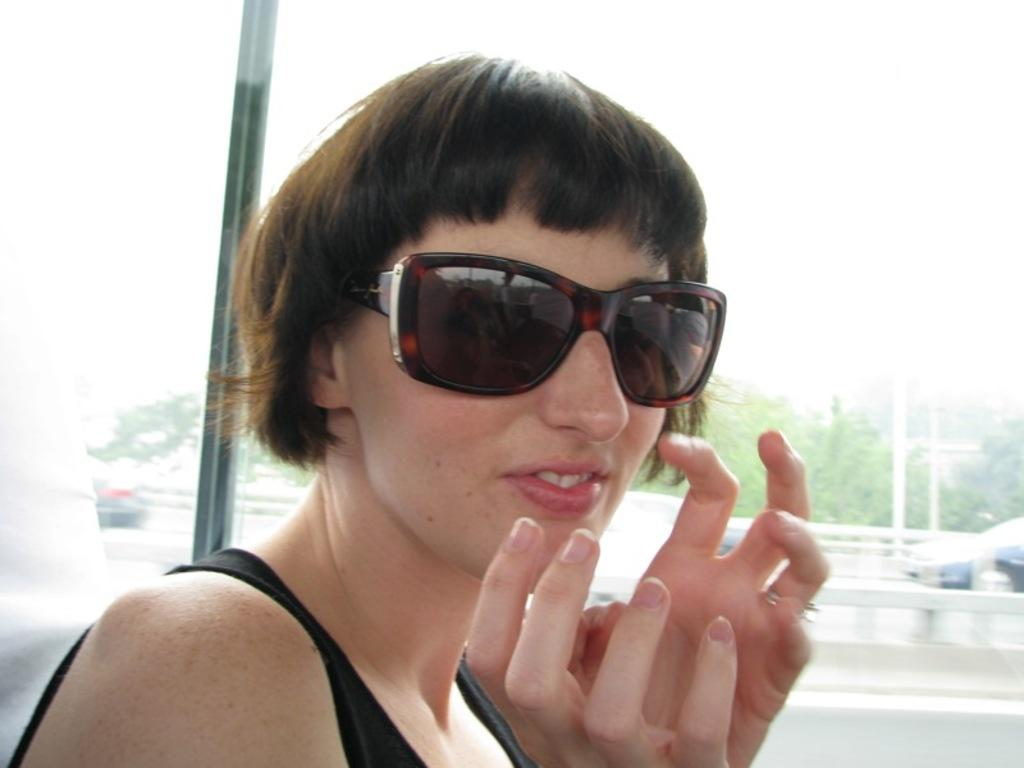Who is present in the image? There is a woman in the image. What material is present in the image that allows for visibility? There is transparent glass in the image. What can be seen through the transparent glass? Vehicles on the road, trees, and the sky are visible through the transparent glass. What type of lock is visible on the furniture in the image? There is no furniture present in the image, and therefore no lock can be observed. What type of badge is the woman wearing in the image? The image does not show the woman wearing any badge. 